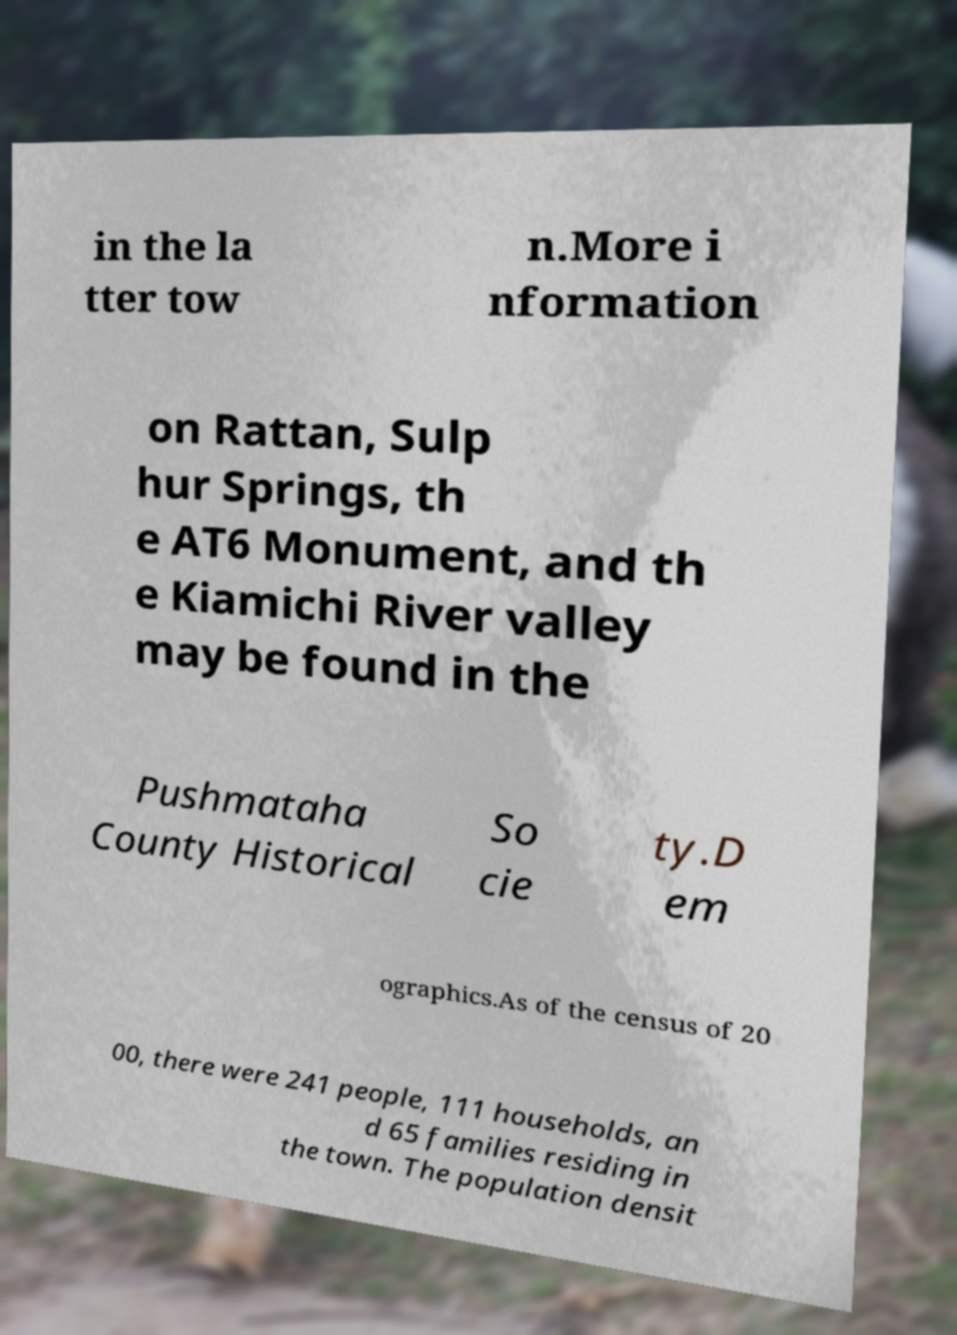What messages or text are displayed in this image? I need them in a readable, typed format. in the la tter tow n.More i nformation on Rattan, Sulp hur Springs, th e AT6 Monument, and th e Kiamichi River valley may be found in the Pushmataha County Historical So cie ty.D em ographics.As of the census of 20 00, there were 241 people, 111 households, an d 65 families residing in the town. The population densit 